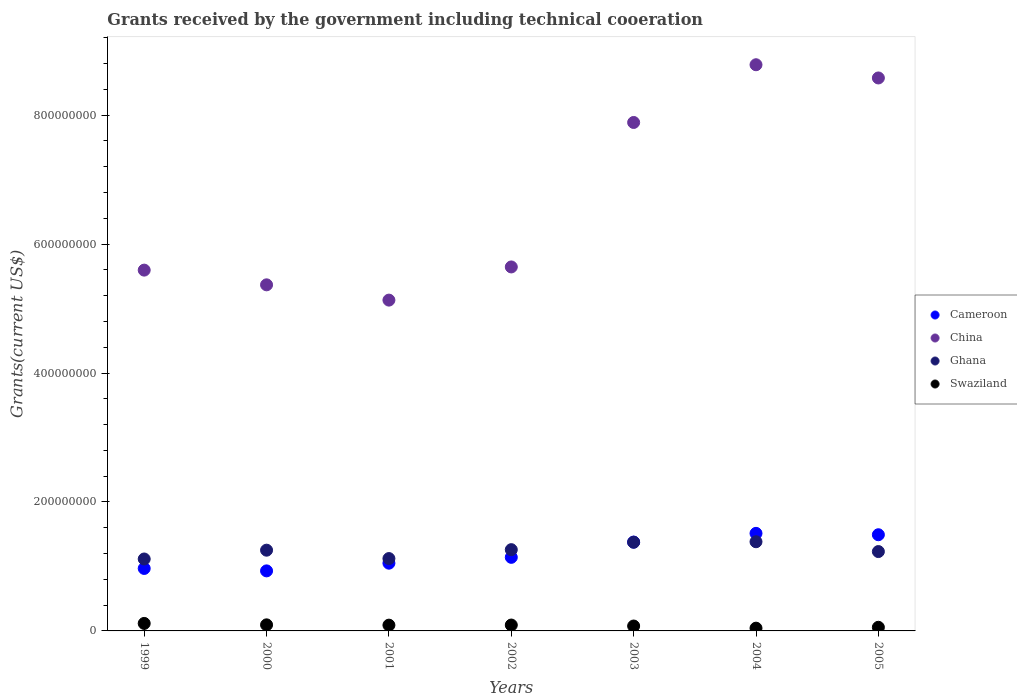How many different coloured dotlines are there?
Offer a very short reply. 4. Is the number of dotlines equal to the number of legend labels?
Provide a succinct answer. Yes. What is the total grants received by the government in Swaziland in 2000?
Offer a very short reply. 9.42e+06. Across all years, what is the maximum total grants received by the government in China?
Your answer should be compact. 8.78e+08. Across all years, what is the minimum total grants received by the government in Cameroon?
Your response must be concise. 9.31e+07. In which year was the total grants received by the government in China maximum?
Your answer should be compact. 2004. What is the total total grants received by the government in China in the graph?
Your answer should be very brief. 4.70e+09. What is the difference between the total grants received by the government in China in 1999 and that in 2003?
Provide a short and direct response. -2.29e+08. What is the difference between the total grants received by the government in Ghana in 1999 and the total grants received by the government in China in 2000?
Provide a succinct answer. -4.25e+08. What is the average total grants received by the government in Swaziland per year?
Give a very brief answer. 8.09e+06. In the year 2004, what is the difference between the total grants received by the government in China and total grants received by the government in Cameroon?
Keep it short and to the point. 7.27e+08. What is the ratio of the total grants received by the government in Swaziland in 2001 to that in 2003?
Offer a terse response. 1.18. Is the total grants received by the government in Ghana in 1999 less than that in 2002?
Your answer should be very brief. Yes. What is the difference between the highest and the second highest total grants received by the government in China?
Provide a short and direct response. 2.05e+07. What is the difference between the highest and the lowest total grants received by the government in Cameroon?
Your response must be concise. 5.82e+07. In how many years, is the total grants received by the government in China greater than the average total grants received by the government in China taken over all years?
Keep it short and to the point. 3. Does the total grants received by the government in Swaziland monotonically increase over the years?
Offer a very short reply. No. Is the total grants received by the government in Swaziland strictly greater than the total grants received by the government in Ghana over the years?
Offer a very short reply. No. How many dotlines are there?
Your answer should be very brief. 4. How many years are there in the graph?
Your answer should be compact. 7. What is the difference between two consecutive major ticks on the Y-axis?
Offer a terse response. 2.00e+08. Are the values on the major ticks of Y-axis written in scientific E-notation?
Offer a terse response. No. Where does the legend appear in the graph?
Your answer should be very brief. Center right. How are the legend labels stacked?
Make the answer very short. Vertical. What is the title of the graph?
Offer a very short reply. Grants received by the government including technical cooeration. Does "Macao" appear as one of the legend labels in the graph?
Provide a short and direct response. No. What is the label or title of the Y-axis?
Offer a terse response. Grants(current US$). What is the Grants(current US$) of Cameroon in 1999?
Give a very brief answer. 9.69e+07. What is the Grants(current US$) in China in 1999?
Give a very brief answer. 5.60e+08. What is the Grants(current US$) of Ghana in 1999?
Ensure brevity in your answer.  1.12e+08. What is the Grants(current US$) in Swaziland in 1999?
Your answer should be very brief. 1.16e+07. What is the Grants(current US$) in Cameroon in 2000?
Offer a very short reply. 9.31e+07. What is the Grants(current US$) in China in 2000?
Offer a terse response. 5.37e+08. What is the Grants(current US$) of Ghana in 2000?
Keep it short and to the point. 1.25e+08. What is the Grants(current US$) in Swaziland in 2000?
Make the answer very short. 9.42e+06. What is the Grants(current US$) of Cameroon in 2001?
Provide a short and direct response. 1.05e+08. What is the Grants(current US$) of China in 2001?
Offer a very short reply. 5.13e+08. What is the Grants(current US$) of Ghana in 2001?
Provide a short and direct response. 1.12e+08. What is the Grants(current US$) in Swaziland in 2001?
Give a very brief answer. 8.96e+06. What is the Grants(current US$) of Cameroon in 2002?
Keep it short and to the point. 1.14e+08. What is the Grants(current US$) of China in 2002?
Your response must be concise. 5.65e+08. What is the Grants(current US$) of Ghana in 2002?
Make the answer very short. 1.26e+08. What is the Grants(current US$) of Swaziland in 2002?
Provide a short and direct response. 9.12e+06. What is the Grants(current US$) in Cameroon in 2003?
Your response must be concise. 1.38e+08. What is the Grants(current US$) of China in 2003?
Offer a terse response. 7.89e+08. What is the Grants(current US$) of Ghana in 2003?
Ensure brevity in your answer.  1.38e+08. What is the Grants(current US$) in Swaziland in 2003?
Your answer should be very brief. 7.60e+06. What is the Grants(current US$) of Cameroon in 2004?
Ensure brevity in your answer.  1.51e+08. What is the Grants(current US$) in China in 2004?
Your answer should be very brief. 8.78e+08. What is the Grants(current US$) in Ghana in 2004?
Ensure brevity in your answer.  1.38e+08. What is the Grants(current US$) in Swaziland in 2004?
Offer a very short reply. 4.28e+06. What is the Grants(current US$) in Cameroon in 2005?
Make the answer very short. 1.49e+08. What is the Grants(current US$) in China in 2005?
Make the answer very short. 8.58e+08. What is the Grants(current US$) of Ghana in 2005?
Make the answer very short. 1.23e+08. What is the Grants(current US$) of Swaziland in 2005?
Offer a very short reply. 5.63e+06. Across all years, what is the maximum Grants(current US$) in Cameroon?
Make the answer very short. 1.51e+08. Across all years, what is the maximum Grants(current US$) in China?
Ensure brevity in your answer.  8.78e+08. Across all years, what is the maximum Grants(current US$) in Ghana?
Keep it short and to the point. 1.38e+08. Across all years, what is the maximum Grants(current US$) of Swaziland?
Your answer should be very brief. 1.16e+07. Across all years, what is the minimum Grants(current US$) in Cameroon?
Your answer should be compact. 9.31e+07. Across all years, what is the minimum Grants(current US$) in China?
Offer a terse response. 5.13e+08. Across all years, what is the minimum Grants(current US$) of Ghana?
Offer a very short reply. 1.12e+08. Across all years, what is the minimum Grants(current US$) of Swaziland?
Ensure brevity in your answer.  4.28e+06. What is the total Grants(current US$) in Cameroon in the graph?
Offer a terse response. 8.47e+08. What is the total Grants(current US$) of China in the graph?
Provide a short and direct response. 4.70e+09. What is the total Grants(current US$) of Ghana in the graph?
Your answer should be very brief. 8.74e+08. What is the total Grants(current US$) in Swaziland in the graph?
Your response must be concise. 5.66e+07. What is the difference between the Grants(current US$) of Cameroon in 1999 and that in 2000?
Offer a very short reply. 3.76e+06. What is the difference between the Grants(current US$) in China in 1999 and that in 2000?
Provide a short and direct response. 2.28e+07. What is the difference between the Grants(current US$) of Ghana in 1999 and that in 2000?
Offer a very short reply. -1.37e+07. What is the difference between the Grants(current US$) of Swaziland in 1999 and that in 2000?
Make the answer very short. 2.21e+06. What is the difference between the Grants(current US$) of Cameroon in 1999 and that in 2001?
Offer a terse response. -8.17e+06. What is the difference between the Grants(current US$) in China in 1999 and that in 2001?
Provide a succinct answer. 4.65e+07. What is the difference between the Grants(current US$) in Ghana in 1999 and that in 2001?
Your answer should be compact. -6.70e+05. What is the difference between the Grants(current US$) of Swaziland in 1999 and that in 2001?
Your response must be concise. 2.67e+06. What is the difference between the Grants(current US$) in Cameroon in 1999 and that in 2002?
Your response must be concise. -1.72e+07. What is the difference between the Grants(current US$) in China in 1999 and that in 2002?
Ensure brevity in your answer.  -4.94e+06. What is the difference between the Grants(current US$) of Ghana in 1999 and that in 2002?
Offer a terse response. -1.45e+07. What is the difference between the Grants(current US$) of Swaziland in 1999 and that in 2002?
Offer a terse response. 2.51e+06. What is the difference between the Grants(current US$) of Cameroon in 1999 and that in 2003?
Ensure brevity in your answer.  -4.09e+07. What is the difference between the Grants(current US$) in China in 1999 and that in 2003?
Offer a very short reply. -2.29e+08. What is the difference between the Grants(current US$) of Ghana in 1999 and that in 2003?
Offer a terse response. -2.60e+07. What is the difference between the Grants(current US$) of Swaziland in 1999 and that in 2003?
Keep it short and to the point. 4.03e+06. What is the difference between the Grants(current US$) in Cameroon in 1999 and that in 2004?
Your answer should be very brief. -5.44e+07. What is the difference between the Grants(current US$) in China in 1999 and that in 2004?
Keep it short and to the point. -3.19e+08. What is the difference between the Grants(current US$) in Ghana in 1999 and that in 2004?
Provide a succinct answer. -2.68e+07. What is the difference between the Grants(current US$) of Swaziland in 1999 and that in 2004?
Your answer should be compact. 7.35e+06. What is the difference between the Grants(current US$) in Cameroon in 1999 and that in 2005?
Offer a terse response. -5.23e+07. What is the difference between the Grants(current US$) in China in 1999 and that in 2005?
Provide a succinct answer. -2.98e+08. What is the difference between the Grants(current US$) of Ghana in 1999 and that in 2005?
Ensure brevity in your answer.  -1.15e+07. What is the difference between the Grants(current US$) in Cameroon in 2000 and that in 2001?
Your answer should be compact. -1.19e+07. What is the difference between the Grants(current US$) in China in 2000 and that in 2001?
Offer a very short reply. 2.37e+07. What is the difference between the Grants(current US$) of Ghana in 2000 and that in 2001?
Your response must be concise. 1.30e+07. What is the difference between the Grants(current US$) in Swaziland in 2000 and that in 2001?
Offer a terse response. 4.60e+05. What is the difference between the Grants(current US$) in Cameroon in 2000 and that in 2002?
Offer a very short reply. -2.10e+07. What is the difference between the Grants(current US$) in China in 2000 and that in 2002?
Offer a very short reply. -2.78e+07. What is the difference between the Grants(current US$) of Ghana in 2000 and that in 2002?
Ensure brevity in your answer.  -8.00e+05. What is the difference between the Grants(current US$) in Swaziland in 2000 and that in 2002?
Ensure brevity in your answer.  3.00e+05. What is the difference between the Grants(current US$) of Cameroon in 2000 and that in 2003?
Give a very brief answer. -4.46e+07. What is the difference between the Grants(current US$) of China in 2000 and that in 2003?
Offer a very short reply. -2.52e+08. What is the difference between the Grants(current US$) in Ghana in 2000 and that in 2003?
Your response must be concise. -1.23e+07. What is the difference between the Grants(current US$) in Swaziland in 2000 and that in 2003?
Make the answer very short. 1.82e+06. What is the difference between the Grants(current US$) of Cameroon in 2000 and that in 2004?
Keep it short and to the point. -5.82e+07. What is the difference between the Grants(current US$) of China in 2000 and that in 2004?
Provide a succinct answer. -3.41e+08. What is the difference between the Grants(current US$) in Ghana in 2000 and that in 2004?
Your response must be concise. -1.31e+07. What is the difference between the Grants(current US$) in Swaziland in 2000 and that in 2004?
Keep it short and to the point. 5.14e+06. What is the difference between the Grants(current US$) in Cameroon in 2000 and that in 2005?
Your response must be concise. -5.60e+07. What is the difference between the Grants(current US$) of China in 2000 and that in 2005?
Give a very brief answer. -3.21e+08. What is the difference between the Grants(current US$) of Ghana in 2000 and that in 2005?
Provide a short and direct response. 2.15e+06. What is the difference between the Grants(current US$) in Swaziland in 2000 and that in 2005?
Provide a succinct answer. 3.79e+06. What is the difference between the Grants(current US$) in Cameroon in 2001 and that in 2002?
Provide a short and direct response. -9.07e+06. What is the difference between the Grants(current US$) in China in 2001 and that in 2002?
Offer a terse response. -5.14e+07. What is the difference between the Grants(current US$) of Ghana in 2001 and that in 2002?
Make the answer very short. -1.38e+07. What is the difference between the Grants(current US$) in Cameroon in 2001 and that in 2003?
Your answer should be compact. -3.27e+07. What is the difference between the Grants(current US$) of China in 2001 and that in 2003?
Your answer should be compact. -2.76e+08. What is the difference between the Grants(current US$) in Ghana in 2001 and that in 2003?
Provide a short and direct response. -2.53e+07. What is the difference between the Grants(current US$) of Swaziland in 2001 and that in 2003?
Offer a terse response. 1.36e+06. What is the difference between the Grants(current US$) in Cameroon in 2001 and that in 2004?
Offer a terse response. -4.63e+07. What is the difference between the Grants(current US$) in China in 2001 and that in 2004?
Give a very brief answer. -3.65e+08. What is the difference between the Grants(current US$) in Ghana in 2001 and that in 2004?
Give a very brief answer. -2.61e+07. What is the difference between the Grants(current US$) in Swaziland in 2001 and that in 2004?
Make the answer very short. 4.68e+06. What is the difference between the Grants(current US$) in Cameroon in 2001 and that in 2005?
Make the answer very short. -4.41e+07. What is the difference between the Grants(current US$) of China in 2001 and that in 2005?
Offer a very short reply. -3.45e+08. What is the difference between the Grants(current US$) in Ghana in 2001 and that in 2005?
Give a very brief answer. -1.08e+07. What is the difference between the Grants(current US$) in Swaziland in 2001 and that in 2005?
Provide a short and direct response. 3.33e+06. What is the difference between the Grants(current US$) of Cameroon in 2002 and that in 2003?
Make the answer very short. -2.36e+07. What is the difference between the Grants(current US$) in China in 2002 and that in 2003?
Make the answer very short. -2.24e+08. What is the difference between the Grants(current US$) of Ghana in 2002 and that in 2003?
Provide a succinct answer. -1.15e+07. What is the difference between the Grants(current US$) in Swaziland in 2002 and that in 2003?
Give a very brief answer. 1.52e+06. What is the difference between the Grants(current US$) of Cameroon in 2002 and that in 2004?
Your answer should be compact. -3.72e+07. What is the difference between the Grants(current US$) of China in 2002 and that in 2004?
Offer a very short reply. -3.14e+08. What is the difference between the Grants(current US$) in Ghana in 2002 and that in 2004?
Offer a very short reply. -1.23e+07. What is the difference between the Grants(current US$) of Swaziland in 2002 and that in 2004?
Keep it short and to the point. 4.84e+06. What is the difference between the Grants(current US$) of Cameroon in 2002 and that in 2005?
Ensure brevity in your answer.  -3.50e+07. What is the difference between the Grants(current US$) of China in 2002 and that in 2005?
Provide a succinct answer. -2.93e+08. What is the difference between the Grants(current US$) in Ghana in 2002 and that in 2005?
Keep it short and to the point. 2.95e+06. What is the difference between the Grants(current US$) of Swaziland in 2002 and that in 2005?
Keep it short and to the point. 3.49e+06. What is the difference between the Grants(current US$) in Cameroon in 2003 and that in 2004?
Provide a short and direct response. -1.35e+07. What is the difference between the Grants(current US$) in China in 2003 and that in 2004?
Offer a terse response. -8.95e+07. What is the difference between the Grants(current US$) of Ghana in 2003 and that in 2004?
Ensure brevity in your answer.  -7.60e+05. What is the difference between the Grants(current US$) of Swaziland in 2003 and that in 2004?
Make the answer very short. 3.32e+06. What is the difference between the Grants(current US$) in Cameroon in 2003 and that in 2005?
Your answer should be compact. -1.14e+07. What is the difference between the Grants(current US$) of China in 2003 and that in 2005?
Make the answer very short. -6.90e+07. What is the difference between the Grants(current US$) in Ghana in 2003 and that in 2005?
Make the answer very short. 1.45e+07. What is the difference between the Grants(current US$) in Swaziland in 2003 and that in 2005?
Your answer should be very brief. 1.97e+06. What is the difference between the Grants(current US$) in Cameroon in 2004 and that in 2005?
Ensure brevity in your answer.  2.14e+06. What is the difference between the Grants(current US$) of China in 2004 and that in 2005?
Your response must be concise. 2.05e+07. What is the difference between the Grants(current US$) in Ghana in 2004 and that in 2005?
Ensure brevity in your answer.  1.52e+07. What is the difference between the Grants(current US$) of Swaziland in 2004 and that in 2005?
Your response must be concise. -1.35e+06. What is the difference between the Grants(current US$) in Cameroon in 1999 and the Grants(current US$) in China in 2000?
Ensure brevity in your answer.  -4.40e+08. What is the difference between the Grants(current US$) in Cameroon in 1999 and the Grants(current US$) in Ghana in 2000?
Make the answer very short. -2.83e+07. What is the difference between the Grants(current US$) of Cameroon in 1999 and the Grants(current US$) of Swaziland in 2000?
Your answer should be very brief. 8.75e+07. What is the difference between the Grants(current US$) of China in 1999 and the Grants(current US$) of Ghana in 2000?
Provide a short and direct response. 4.34e+08. What is the difference between the Grants(current US$) of China in 1999 and the Grants(current US$) of Swaziland in 2000?
Your answer should be compact. 5.50e+08. What is the difference between the Grants(current US$) of Ghana in 1999 and the Grants(current US$) of Swaziland in 2000?
Offer a terse response. 1.02e+08. What is the difference between the Grants(current US$) of Cameroon in 1999 and the Grants(current US$) of China in 2001?
Make the answer very short. -4.16e+08. What is the difference between the Grants(current US$) in Cameroon in 1999 and the Grants(current US$) in Ghana in 2001?
Your answer should be compact. -1.53e+07. What is the difference between the Grants(current US$) in Cameroon in 1999 and the Grants(current US$) in Swaziland in 2001?
Provide a short and direct response. 8.79e+07. What is the difference between the Grants(current US$) of China in 1999 and the Grants(current US$) of Ghana in 2001?
Offer a terse response. 4.47e+08. What is the difference between the Grants(current US$) in China in 1999 and the Grants(current US$) in Swaziland in 2001?
Provide a succinct answer. 5.51e+08. What is the difference between the Grants(current US$) in Ghana in 1999 and the Grants(current US$) in Swaziland in 2001?
Provide a short and direct response. 1.03e+08. What is the difference between the Grants(current US$) in Cameroon in 1999 and the Grants(current US$) in China in 2002?
Give a very brief answer. -4.68e+08. What is the difference between the Grants(current US$) of Cameroon in 1999 and the Grants(current US$) of Ghana in 2002?
Ensure brevity in your answer.  -2.91e+07. What is the difference between the Grants(current US$) in Cameroon in 1999 and the Grants(current US$) in Swaziland in 2002?
Your answer should be compact. 8.78e+07. What is the difference between the Grants(current US$) of China in 1999 and the Grants(current US$) of Ghana in 2002?
Your answer should be compact. 4.34e+08. What is the difference between the Grants(current US$) in China in 1999 and the Grants(current US$) in Swaziland in 2002?
Offer a terse response. 5.50e+08. What is the difference between the Grants(current US$) of Ghana in 1999 and the Grants(current US$) of Swaziland in 2002?
Offer a terse response. 1.02e+08. What is the difference between the Grants(current US$) of Cameroon in 1999 and the Grants(current US$) of China in 2003?
Your answer should be compact. -6.92e+08. What is the difference between the Grants(current US$) of Cameroon in 1999 and the Grants(current US$) of Ghana in 2003?
Offer a very short reply. -4.07e+07. What is the difference between the Grants(current US$) of Cameroon in 1999 and the Grants(current US$) of Swaziland in 2003?
Offer a terse response. 8.93e+07. What is the difference between the Grants(current US$) in China in 1999 and the Grants(current US$) in Ghana in 2003?
Offer a terse response. 4.22e+08. What is the difference between the Grants(current US$) of China in 1999 and the Grants(current US$) of Swaziland in 2003?
Provide a short and direct response. 5.52e+08. What is the difference between the Grants(current US$) in Ghana in 1999 and the Grants(current US$) in Swaziland in 2003?
Your response must be concise. 1.04e+08. What is the difference between the Grants(current US$) of Cameroon in 1999 and the Grants(current US$) of China in 2004?
Keep it short and to the point. -7.81e+08. What is the difference between the Grants(current US$) in Cameroon in 1999 and the Grants(current US$) in Ghana in 2004?
Keep it short and to the point. -4.14e+07. What is the difference between the Grants(current US$) in Cameroon in 1999 and the Grants(current US$) in Swaziland in 2004?
Offer a very short reply. 9.26e+07. What is the difference between the Grants(current US$) of China in 1999 and the Grants(current US$) of Ghana in 2004?
Provide a succinct answer. 4.21e+08. What is the difference between the Grants(current US$) in China in 1999 and the Grants(current US$) in Swaziland in 2004?
Your answer should be compact. 5.55e+08. What is the difference between the Grants(current US$) of Ghana in 1999 and the Grants(current US$) of Swaziland in 2004?
Give a very brief answer. 1.07e+08. What is the difference between the Grants(current US$) of Cameroon in 1999 and the Grants(current US$) of China in 2005?
Provide a succinct answer. -7.61e+08. What is the difference between the Grants(current US$) in Cameroon in 1999 and the Grants(current US$) in Ghana in 2005?
Make the answer very short. -2.62e+07. What is the difference between the Grants(current US$) in Cameroon in 1999 and the Grants(current US$) in Swaziland in 2005?
Provide a short and direct response. 9.13e+07. What is the difference between the Grants(current US$) of China in 1999 and the Grants(current US$) of Ghana in 2005?
Your answer should be compact. 4.37e+08. What is the difference between the Grants(current US$) in China in 1999 and the Grants(current US$) in Swaziland in 2005?
Your response must be concise. 5.54e+08. What is the difference between the Grants(current US$) in Ghana in 1999 and the Grants(current US$) in Swaziland in 2005?
Provide a succinct answer. 1.06e+08. What is the difference between the Grants(current US$) in Cameroon in 2000 and the Grants(current US$) in China in 2001?
Make the answer very short. -4.20e+08. What is the difference between the Grants(current US$) of Cameroon in 2000 and the Grants(current US$) of Ghana in 2001?
Your answer should be very brief. -1.91e+07. What is the difference between the Grants(current US$) of Cameroon in 2000 and the Grants(current US$) of Swaziland in 2001?
Your answer should be compact. 8.42e+07. What is the difference between the Grants(current US$) in China in 2000 and the Grants(current US$) in Ghana in 2001?
Your answer should be compact. 4.25e+08. What is the difference between the Grants(current US$) in China in 2000 and the Grants(current US$) in Swaziland in 2001?
Make the answer very short. 5.28e+08. What is the difference between the Grants(current US$) in Ghana in 2000 and the Grants(current US$) in Swaziland in 2001?
Ensure brevity in your answer.  1.16e+08. What is the difference between the Grants(current US$) of Cameroon in 2000 and the Grants(current US$) of China in 2002?
Keep it short and to the point. -4.71e+08. What is the difference between the Grants(current US$) of Cameroon in 2000 and the Grants(current US$) of Ghana in 2002?
Give a very brief answer. -3.29e+07. What is the difference between the Grants(current US$) in Cameroon in 2000 and the Grants(current US$) in Swaziland in 2002?
Give a very brief answer. 8.40e+07. What is the difference between the Grants(current US$) of China in 2000 and the Grants(current US$) of Ghana in 2002?
Your answer should be very brief. 4.11e+08. What is the difference between the Grants(current US$) in China in 2000 and the Grants(current US$) in Swaziland in 2002?
Offer a very short reply. 5.28e+08. What is the difference between the Grants(current US$) of Ghana in 2000 and the Grants(current US$) of Swaziland in 2002?
Provide a succinct answer. 1.16e+08. What is the difference between the Grants(current US$) in Cameroon in 2000 and the Grants(current US$) in China in 2003?
Your response must be concise. -6.95e+08. What is the difference between the Grants(current US$) in Cameroon in 2000 and the Grants(current US$) in Ghana in 2003?
Offer a very short reply. -4.44e+07. What is the difference between the Grants(current US$) of Cameroon in 2000 and the Grants(current US$) of Swaziland in 2003?
Your answer should be compact. 8.55e+07. What is the difference between the Grants(current US$) of China in 2000 and the Grants(current US$) of Ghana in 2003?
Your response must be concise. 3.99e+08. What is the difference between the Grants(current US$) in China in 2000 and the Grants(current US$) in Swaziland in 2003?
Make the answer very short. 5.29e+08. What is the difference between the Grants(current US$) of Ghana in 2000 and the Grants(current US$) of Swaziland in 2003?
Provide a short and direct response. 1.18e+08. What is the difference between the Grants(current US$) of Cameroon in 2000 and the Grants(current US$) of China in 2004?
Ensure brevity in your answer.  -7.85e+08. What is the difference between the Grants(current US$) in Cameroon in 2000 and the Grants(current US$) in Ghana in 2004?
Your answer should be compact. -4.52e+07. What is the difference between the Grants(current US$) of Cameroon in 2000 and the Grants(current US$) of Swaziland in 2004?
Your response must be concise. 8.88e+07. What is the difference between the Grants(current US$) of China in 2000 and the Grants(current US$) of Ghana in 2004?
Your answer should be compact. 3.98e+08. What is the difference between the Grants(current US$) in China in 2000 and the Grants(current US$) in Swaziland in 2004?
Your response must be concise. 5.33e+08. What is the difference between the Grants(current US$) of Ghana in 2000 and the Grants(current US$) of Swaziland in 2004?
Give a very brief answer. 1.21e+08. What is the difference between the Grants(current US$) of Cameroon in 2000 and the Grants(current US$) of China in 2005?
Provide a short and direct response. -7.65e+08. What is the difference between the Grants(current US$) in Cameroon in 2000 and the Grants(current US$) in Ghana in 2005?
Offer a very short reply. -3.00e+07. What is the difference between the Grants(current US$) in Cameroon in 2000 and the Grants(current US$) in Swaziland in 2005?
Offer a terse response. 8.75e+07. What is the difference between the Grants(current US$) of China in 2000 and the Grants(current US$) of Ghana in 2005?
Give a very brief answer. 4.14e+08. What is the difference between the Grants(current US$) in China in 2000 and the Grants(current US$) in Swaziland in 2005?
Make the answer very short. 5.31e+08. What is the difference between the Grants(current US$) in Ghana in 2000 and the Grants(current US$) in Swaziland in 2005?
Your answer should be compact. 1.20e+08. What is the difference between the Grants(current US$) of Cameroon in 2001 and the Grants(current US$) of China in 2002?
Offer a very short reply. -4.59e+08. What is the difference between the Grants(current US$) in Cameroon in 2001 and the Grants(current US$) in Ghana in 2002?
Ensure brevity in your answer.  -2.10e+07. What is the difference between the Grants(current US$) in Cameroon in 2001 and the Grants(current US$) in Swaziland in 2002?
Provide a succinct answer. 9.59e+07. What is the difference between the Grants(current US$) in China in 2001 and the Grants(current US$) in Ghana in 2002?
Provide a short and direct response. 3.87e+08. What is the difference between the Grants(current US$) in China in 2001 and the Grants(current US$) in Swaziland in 2002?
Provide a short and direct response. 5.04e+08. What is the difference between the Grants(current US$) in Ghana in 2001 and the Grants(current US$) in Swaziland in 2002?
Your response must be concise. 1.03e+08. What is the difference between the Grants(current US$) of Cameroon in 2001 and the Grants(current US$) of China in 2003?
Provide a succinct answer. -6.84e+08. What is the difference between the Grants(current US$) of Cameroon in 2001 and the Grants(current US$) of Ghana in 2003?
Make the answer very short. -3.25e+07. What is the difference between the Grants(current US$) in Cameroon in 2001 and the Grants(current US$) in Swaziland in 2003?
Provide a short and direct response. 9.75e+07. What is the difference between the Grants(current US$) in China in 2001 and the Grants(current US$) in Ghana in 2003?
Provide a succinct answer. 3.76e+08. What is the difference between the Grants(current US$) of China in 2001 and the Grants(current US$) of Swaziland in 2003?
Provide a short and direct response. 5.05e+08. What is the difference between the Grants(current US$) in Ghana in 2001 and the Grants(current US$) in Swaziland in 2003?
Offer a terse response. 1.05e+08. What is the difference between the Grants(current US$) in Cameroon in 2001 and the Grants(current US$) in China in 2004?
Your response must be concise. -7.73e+08. What is the difference between the Grants(current US$) in Cameroon in 2001 and the Grants(current US$) in Ghana in 2004?
Give a very brief answer. -3.32e+07. What is the difference between the Grants(current US$) of Cameroon in 2001 and the Grants(current US$) of Swaziland in 2004?
Provide a succinct answer. 1.01e+08. What is the difference between the Grants(current US$) in China in 2001 and the Grants(current US$) in Ghana in 2004?
Provide a short and direct response. 3.75e+08. What is the difference between the Grants(current US$) of China in 2001 and the Grants(current US$) of Swaziland in 2004?
Offer a very short reply. 5.09e+08. What is the difference between the Grants(current US$) in Ghana in 2001 and the Grants(current US$) in Swaziland in 2004?
Provide a succinct answer. 1.08e+08. What is the difference between the Grants(current US$) of Cameroon in 2001 and the Grants(current US$) of China in 2005?
Provide a succinct answer. -7.53e+08. What is the difference between the Grants(current US$) in Cameroon in 2001 and the Grants(current US$) in Ghana in 2005?
Your answer should be compact. -1.80e+07. What is the difference between the Grants(current US$) of Cameroon in 2001 and the Grants(current US$) of Swaziland in 2005?
Provide a short and direct response. 9.94e+07. What is the difference between the Grants(current US$) in China in 2001 and the Grants(current US$) in Ghana in 2005?
Your response must be concise. 3.90e+08. What is the difference between the Grants(current US$) of China in 2001 and the Grants(current US$) of Swaziland in 2005?
Your answer should be very brief. 5.07e+08. What is the difference between the Grants(current US$) of Ghana in 2001 and the Grants(current US$) of Swaziland in 2005?
Your answer should be compact. 1.07e+08. What is the difference between the Grants(current US$) in Cameroon in 2002 and the Grants(current US$) in China in 2003?
Offer a very short reply. -6.74e+08. What is the difference between the Grants(current US$) in Cameroon in 2002 and the Grants(current US$) in Ghana in 2003?
Give a very brief answer. -2.34e+07. What is the difference between the Grants(current US$) of Cameroon in 2002 and the Grants(current US$) of Swaziland in 2003?
Ensure brevity in your answer.  1.07e+08. What is the difference between the Grants(current US$) in China in 2002 and the Grants(current US$) in Ghana in 2003?
Your answer should be compact. 4.27e+08. What is the difference between the Grants(current US$) in China in 2002 and the Grants(current US$) in Swaziland in 2003?
Ensure brevity in your answer.  5.57e+08. What is the difference between the Grants(current US$) of Ghana in 2002 and the Grants(current US$) of Swaziland in 2003?
Make the answer very short. 1.18e+08. What is the difference between the Grants(current US$) of Cameroon in 2002 and the Grants(current US$) of China in 2004?
Provide a short and direct response. -7.64e+08. What is the difference between the Grants(current US$) in Cameroon in 2002 and the Grants(current US$) in Ghana in 2004?
Make the answer very short. -2.42e+07. What is the difference between the Grants(current US$) in Cameroon in 2002 and the Grants(current US$) in Swaziland in 2004?
Your answer should be compact. 1.10e+08. What is the difference between the Grants(current US$) in China in 2002 and the Grants(current US$) in Ghana in 2004?
Make the answer very short. 4.26e+08. What is the difference between the Grants(current US$) of China in 2002 and the Grants(current US$) of Swaziland in 2004?
Provide a succinct answer. 5.60e+08. What is the difference between the Grants(current US$) of Ghana in 2002 and the Grants(current US$) of Swaziland in 2004?
Provide a short and direct response. 1.22e+08. What is the difference between the Grants(current US$) of Cameroon in 2002 and the Grants(current US$) of China in 2005?
Your response must be concise. -7.44e+08. What is the difference between the Grants(current US$) in Cameroon in 2002 and the Grants(current US$) in Ghana in 2005?
Give a very brief answer. -8.95e+06. What is the difference between the Grants(current US$) in Cameroon in 2002 and the Grants(current US$) in Swaziland in 2005?
Offer a very short reply. 1.08e+08. What is the difference between the Grants(current US$) of China in 2002 and the Grants(current US$) of Ghana in 2005?
Your answer should be very brief. 4.41e+08. What is the difference between the Grants(current US$) of China in 2002 and the Grants(current US$) of Swaziland in 2005?
Offer a terse response. 5.59e+08. What is the difference between the Grants(current US$) of Ghana in 2002 and the Grants(current US$) of Swaziland in 2005?
Keep it short and to the point. 1.20e+08. What is the difference between the Grants(current US$) of Cameroon in 2003 and the Grants(current US$) of China in 2004?
Offer a terse response. -7.40e+08. What is the difference between the Grants(current US$) in Cameroon in 2003 and the Grants(current US$) in Ghana in 2004?
Your answer should be very brief. -5.30e+05. What is the difference between the Grants(current US$) in Cameroon in 2003 and the Grants(current US$) in Swaziland in 2004?
Offer a very short reply. 1.34e+08. What is the difference between the Grants(current US$) of China in 2003 and the Grants(current US$) of Ghana in 2004?
Your response must be concise. 6.50e+08. What is the difference between the Grants(current US$) of China in 2003 and the Grants(current US$) of Swaziland in 2004?
Keep it short and to the point. 7.84e+08. What is the difference between the Grants(current US$) of Ghana in 2003 and the Grants(current US$) of Swaziland in 2004?
Your response must be concise. 1.33e+08. What is the difference between the Grants(current US$) in Cameroon in 2003 and the Grants(current US$) in China in 2005?
Offer a terse response. -7.20e+08. What is the difference between the Grants(current US$) of Cameroon in 2003 and the Grants(current US$) of Ghana in 2005?
Make the answer very short. 1.47e+07. What is the difference between the Grants(current US$) in Cameroon in 2003 and the Grants(current US$) in Swaziland in 2005?
Provide a succinct answer. 1.32e+08. What is the difference between the Grants(current US$) in China in 2003 and the Grants(current US$) in Ghana in 2005?
Provide a short and direct response. 6.66e+08. What is the difference between the Grants(current US$) in China in 2003 and the Grants(current US$) in Swaziland in 2005?
Ensure brevity in your answer.  7.83e+08. What is the difference between the Grants(current US$) in Ghana in 2003 and the Grants(current US$) in Swaziland in 2005?
Your answer should be very brief. 1.32e+08. What is the difference between the Grants(current US$) of Cameroon in 2004 and the Grants(current US$) of China in 2005?
Your answer should be compact. -7.06e+08. What is the difference between the Grants(current US$) in Cameroon in 2004 and the Grants(current US$) in Ghana in 2005?
Ensure brevity in your answer.  2.82e+07. What is the difference between the Grants(current US$) of Cameroon in 2004 and the Grants(current US$) of Swaziland in 2005?
Offer a very short reply. 1.46e+08. What is the difference between the Grants(current US$) in China in 2004 and the Grants(current US$) in Ghana in 2005?
Keep it short and to the point. 7.55e+08. What is the difference between the Grants(current US$) in China in 2004 and the Grants(current US$) in Swaziland in 2005?
Provide a short and direct response. 8.73e+08. What is the difference between the Grants(current US$) in Ghana in 2004 and the Grants(current US$) in Swaziland in 2005?
Give a very brief answer. 1.33e+08. What is the average Grants(current US$) of Cameroon per year?
Keep it short and to the point. 1.21e+08. What is the average Grants(current US$) of China per year?
Keep it short and to the point. 6.71e+08. What is the average Grants(current US$) in Ghana per year?
Ensure brevity in your answer.  1.25e+08. What is the average Grants(current US$) of Swaziland per year?
Provide a succinct answer. 8.09e+06. In the year 1999, what is the difference between the Grants(current US$) in Cameroon and Grants(current US$) in China?
Give a very brief answer. -4.63e+08. In the year 1999, what is the difference between the Grants(current US$) in Cameroon and Grants(current US$) in Ghana?
Offer a very short reply. -1.47e+07. In the year 1999, what is the difference between the Grants(current US$) of Cameroon and Grants(current US$) of Swaziland?
Keep it short and to the point. 8.53e+07. In the year 1999, what is the difference between the Grants(current US$) in China and Grants(current US$) in Ghana?
Offer a very short reply. 4.48e+08. In the year 1999, what is the difference between the Grants(current US$) of China and Grants(current US$) of Swaziland?
Your answer should be compact. 5.48e+08. In the year 1999, what is the difference between the Grants(current US$) in Ghana and Grants(current US$) in Swaziland?
Offer a terse response. 9.99e+07. In the year 2000, what is the difference between the Grants(current US$) in Cameroon and Grants(current US$) in China?
Offer a very short reply. -4.44e+08. In the year 2000, what is the difference between the Grants(current US$) in Cameroon and Grants(current US$) in Ghana?
Ensure brevity in your answer.  -3.21e+07. In the year 2000, what is the difference between the Grants(current US$) in Cameroon and Grants(current US$) in Swaziland?
Your answer should be very brief. 8.37e+07. In the year 2000, what is the difference between the Grants(current US$) of China and Grants(current US$) of Ghana?
Provide a succinct answer. 4.12e+08. In the year 2000, what is the difference between the Grants(current US$) of China and Grants(current US$) of Swaziland?
Offer a very short reply. 5.27e+08. In the year 2000, what is the difference between the Grants(current US$) in Ghana and Grants(current US$) in Swaziland?
Offer a terse response. 1.16e+08. In the year 2001, what is the difference between the Grants(current US$) in Cameroon and Grants(current US$) in China?
Offer a terse response. -4.08e+08. In the year 2001, what is the difference between the Grants(current US$) in Cameroon and Grants(current US$) in Ghana?
Your answer should be compact. -7.17e+06. In the year 2001, what is the difference between the Grants(current US$) in Cameroon and Grants(current US$) in Swaziland?
Provide a succinct answer. 9.61e+07. In the year 2001, what is the difference between the Grants(current US$) in China and Grants(current US$) in Ghana?
Your response must be concise. 4.01e+08. In the year 2001, what is the difference between the Grants(current US$) of China and Grants(current US$) of Swaziland?
Your response must be concise. 5.04e+08. In the year 2001, what is the difference between the Grants(current US$) of Ghana and Grants(current US$) of Swaziland?
Keep it short and to the point. 1.03e+08. In the year 2002, what is the difference between the Grants(current US$) of Cameroon and Grants(current US$) of China?
Your answer should be very brief. -4.50e+08. In the year 2002, what is the difference between the Grants(current US$) in Cameroon and Grants(current US$) in Ghana?
Ensure brevity in your answer.  -1.19e+07. In the year 2002, what is the difference between the Grants(current US$) of Cameroon and Grants(current US$) of Swaziland?
Offer a very short reply. 1.05e+08. In the year 2002, what is the difference between the Grants(current US$) of China and Grants(current US$) of Ghana?
Your answer should be very brief. 4.39e+08. In the year 2002, what is the difference between the Grants(current US$) of China and Grants(current US$) of Swaziland?
Make the answer very short. 5.55e+08. In the year 2002, what is the difference between the Grants(current US$) of Ghana and Grants(current US$) of Swaziland?
Your answer should be compact. 1.17e+08. In the year 2003, what is the difference between the Grants(current US$) of Cameroon and Grants(current US$) of China?
Offer a terse response. -6.51e+08. In the year 2003, what is the difference between the Grants(current US$) of Cameroon and Grants(current US$) of Swaziland?
Give a very brief answer. 1.30e+08. In the year 2003, what is the difference between the Grants(current US$) in China and Grants(current US$) in Ghana?
Your response must be concise. 6.51e+08. In the year 2003, what is the difference between the Grants(current US$) of China and Grants(current US$) of Swaziland?
Provide a succinct answer. 7.81e+08. In the year 2003, what is the difference between the Grants(current US$) of Ghana and Grants(current US$) of Swaziland?
Provide a short and direct response. 1.30e+08. In the year 2004, what is the difference between the Grants(current US$) of Cameroon and Grants(current US$) of China?
Offer a very short reply. -7.27e+08. In the year 2004, what is the difference between the Grants(current US$) of Cameroon and Grants(current US$) of Ghana?
Provide a short and direct response. 1.30e+07. In the year 2004, what is the difference between the Grants(current US$) in Cameroon and Grants(current US$) in Swaziland?
Provide a short and direct response. 1.47e+08. In the year 2004, what is the difference between the Grants(current US$) in China and Grants(current US$) in Ghana?
Make the answer very short. 7.40e+08. In the year 2004, what is the difference between the Grants(current US$) of China and Grants(current US$) of Swaziland?
Provide a succinct answer. 8.74e+08. In the year 2004, what is the difference between the Grants(current US$) of Ghana and Grants(current US$) of Swaziland?
Make the answer very short. 1.34e+08. In the year 2005, what is the difference between the Grants(current US$) in Cameroon and Grants(current US$) in China?
Give a very brief answer. -7.08e+08. In the year 2005, what is the difference between the Grants(current US$) of Cameroon and Grants(current US$) of Ghana?
Your answer should be compact. 2.61e+07. In the year 2005, what is the difference between the Grants(current US$) in Cameroon and Grants(current US$) in Swaziland?
Make the answer very short. 1.44e+08. In the year 2005, what is the difference between the Grants(current US$) in China and Grants(current US$) in Ghana?
Provide a short and direct response. 7.35e+08. In the year 2005, what is the difference between the Grants(current US$) in China and Grants(current US$) in Swaziland?
Make the answer very short. 8.52e+08. In the year 2005, what is the difference between the Grants(current US$) of Ghana and Grants(current US$) of Swaziland?
Provide a succinct answer. 1.17e+08. What is the ratio of the Grants(current US$) in Cameroon in 1999 to that in 2000?
Offer a very short reply. 1.04. What is the ratio of the Grants(current US$) of China in 1999 to that in 2000?
Offer a very short reply. 1.04. What is the ratio of the Grants(current US$) in Ghana in 1999 to that in 2000?
Ensure brevity in your answer.  0.89. What is the ratio of the Grants(current US$) in Swaziland in 1999 to that in 2000?
Your response must be concise. 1.23. What is the ratio of the Grants(current US$) of Cameroon in 1999 to that in 2001?
Provide a succinct answer. 0.92. What is the ratio of the Grants(current US$) in China in 1999 to that in 2001?
Make the answer very short. 1.09. What is the ratio of the Grants(current US$) in Ghana in 1999 to that in 2001?
Provide a succinct answer. 0.99. What is the ratio of the Grants(current US$) in Swaziland in 1999 to that in 2001?
Make the answer very short. 1.3. What is the ratio of the Grants(current US$) of Cameroon in 1999 to that in 2002?
Provide a short and direct response. 0.85. What is the ratio of the Grants(current US$) of China in 1999 to that in 2002?
Your answer should be very brief. 0.99. What is the ratio of the Grants(current US$) of Ghana in 1999 to that in 2002?
Your response must be concise. 0.89. What is the ratio of the Grants(current US$) in Swaziland in 1999 to that in 2002?
Offer a terse response. 1.28. What is the ratio of the Grants(current US$) in Cameroon in 1999 to that in 2003?
Give a very brief answer. 0.7. What is the ratio of the Grants(current US$) of China in 1999 to that in 2003?
Your answer should be compact. 0.71. What is the ratio of the Grants(current US$) in Ghana in 1999 to that in 2003?
Offer a very short reply. 0.81. What is the ratio of the Grants(current US$) in Swaziland in 1999 to that in 2003?
Your answer should be very brief. 1.53. What is the ratio of the Grants(current US$) in Cameroon in 1999 to that in 2004?
Ensure brevity in your answer.  0.64. What is the ratio of the Grants(current US$) in China in 1999 to that in 2004?
Make the answer very short. 0.64. What is the ratio of the Grants(current US$) in Ghana in 1999 to that in 2004?
Offer a very short reply. 0.81. What is the ratio of the Grants(current US$) in Swaziland in 1999 to that in 2004?
Ensure brevity in your answer.  2.72. What is the ratio of the Grants(current US$) in Cameroon in 1999 to that in 2005?
Offer a terse response. 0.65. What is the ratio of the Grants(current US$) in China in 1999 to that in 2005?
Ensure brevity in your answer.  0.65. What is the ratio of the Grants(current US$) in Ghana in 1999 to that in 2005?
Make the answer very short. 0.91. What is the ratio of the Grants(current US$) in Swaziland in 1999 to that in 2005?
Give a very brief answer. 2.07. What is the ratio of the Grants(current US$) of Cameroon in 2000 to that in 2001?
Keep it short and to the point. 0.89. What is the ratio of the Grants(current US$) in China in 2000 to that in 2001?
Keep it short and to the point. 1.05. What is the ratio of the Grants(current US$) of Ghana in 2000 to that in 2001?
Keep it short and to the point. 1.12. What is the ratio of the Grants(current US$) of Swaziland in 2000 to that in 2001?
Provide a short and direct response. 1.05. What is the ratio of the Grants(current US$) in Cameroon in 2000 to that in 2002?
Offer a terse response. 0.82. What is the ratio of the Grants(current US$) of China in 2000 to that in 2002?
Your response must be concise. 0.95. What is the ratio of the Grants(current US$) of Ghana in 2000 to that in 2002?
Give a very brief answer. 0.99. What is the ratio of the Grants(current US$) in Swaziland in 2000 to that in 2002?
Give a very brief answer. 1.03. What is the ratio of the Grants(current US$) of Cameroon in 2000 to that in 2003?
Make the answer very short. 0.68. What is the ratio of the Grants(current US$) in China in 2000 to that in 2003?
Offer a terse response. 0.68. What is the ratio of the Grants(current US$) of Ghana in 2000 to that in 2003?
Keep it short and to the point. 0.91. What is the ratio of the Grants(current US$) of Swaziland in 2000 to that in 2003?
Your answer should be very brief. 1.24. What is the ratio of the Grants(current US$) of Cameroon in 2000 to that in 2004?
Ensure brevity in your answer.  0.62. What is the ratio of the Grants(current US$) of China in 2000 to that in 2004?
Keep it short and to the point. 0.61. What is the ratio of the Grants(current US$) of Ghana in 2000 to that in 2004?
Offer a very short reply. 0.91. What is the ratio of the Grants(current US$) of Swaziland in 2000 to that in 2004?
Offer a terse response. 2.2. What is the ratio of the Grants(current US$) in Cameroon in 2000 to that in 2005?
Provide a short and direct response. 0.62. What is the ratio of the Grants(current US$) of China in 2000 to that in 2005?
Offer a very short reply. 0.63. What is the ratio of the Grants(current US$) in Ghana in 2000 to that in 2005?
Offer a very short reply. 1.02. What is the ratio of the Grants(current US$) in Swaziland in 2000 to that in 2005?
Give a very brief answer. 1.67. What is the ratio of the Grants(current US$) of Cameroon in 2001 to that in 2002?
Your answer should be compact. 0.92. What is the ratio of the Grants(current US$) of China in 2001 to that in 2002?
Provide a succinct answer. 0.91. What is the ratio of the Grants(current US$) of Ghana in 2001 to that in 2002?
Give a very brief answer. 0.89. What is the ratio of the Grants(current US$) of Swaziland in 2001 to that in 2002?
Offer a terse response. 0.98. What is the ratio of the Grants(current US$) of Cameroon in 2001 to that in 2003?
Provide a short and direct response. 0.76. What is the ratio of the Grants(current US$) in China in 2001 to that in 2003?
Offer a very short reply. 0.65. What is the ratio of the Grants(current US$) in Ghana in 2001 to that in 2003?
Provide a short and direct response. 0.82. What is the ratio of the Grants(current US$) of Swaziland in 2001 to that in 2003?
Provide a short and direct response. 1.18. What is the ratio of the Grants(current US$) of Cameroon in 2001 to that in 2004?
Ensure brevity in your answer.  0.69. What is the ratio of the Grants(current US$) in China in 2001 to that in 2004?
Provide a short and direct response. 0.58. What is the ratio of the Grants(current US$) of Ghana in 2001 to that in 2004?
Offer a terse response. 0.81. What is the ratio of the Grants(current US$) in Swaziland in 2001 to that in 2004?
Offer a terse response. 2.09. What is the ratio of the Grants(current US$) of Cameroon in 2001 to that in 2005?
Keep it short and to the point. 0.7. What is the ratio of the Grants(current US$) of China in 2001 to that in 2005?
Offer a terse response. 0.6. What is the ratio of the Grants(current US$) in Ghana in 2001 to that in 2005?
Provide a short and direct response. 0.91. What is the ratio of the Grants(current US$) of Swaziland in 2001 to that in 2005?
Your answer should be very brief. 1.59. What is the ratio of the Grants(current US$) in Cameroon in 2002 to that in 2003?
Your response must be concise. 0.83. What is the ratio of the Grants(current US$) in China in 2002 to that in 2003?
Your answer should be very brief. 0.72. What is the ratio of the Grants(current US$) in Ghana in 2002 to that in 2003?
Offer a very short reply. 0.92. What is the ratio of the Grants(current US$) of Cameroon in 2002 to that in 2004?
Your answer should be compact. 0.75. What is the ratio of the Grants(current US$) in China in 2002 to that in 2004?
Give a very brief answer. 0.64. What is the ratio of the Grants(current US$) in Ghana in 2002 to that in 2004?
Ensure brevity in your answer.  0.91. What is the ratio of the Grants(current US$) of Swaziland in 2002 to that in 2004?
Provide a short and direct response. 2.13. What is the ratio of the Grants(current US$) of Cameroon in 2002 to that in 2005?
Your answer should be very brief. 0.77. What is the ratio of the Grants(current US$) of China in 2002 to that in 2005?
Ensure brevity in your answer.  0.66. What is the ratio of the Grants(current US$) in Swaziland in 2002 to that in 2005?
Offer a terse response. 1.62. What is the ratio of the Grants(current US$) in Cameroon in 2003 to that in 2004?
Make the answer very short. 0.91. What is the ratio of the Grants(current US$) of China in 2003 to that in 2004?
Provide a succinct answer. 0.9. What is the ratio of the Grants(current US$) in Swaziland in 2003 to that in 2004?
Give a very brief answer. 1.78. What is the ratio of the Grants(current US$) in Cameroon in 2003 to that in 2005?
Give a very brief answer. 0.92. What is the ratio of the Grants(current US$) of China in 2003 to that in 2005?
Give a very brief answer. 0.92. What is the ratio of the Grants(current US$) of Ghana in 2003 to that in 2005?
Offer a very short reply. 1.12. What is the ratio of the Grants(current US$) of Swaziland in 2003 to that in 2005?
Offer a terse response. 1.35. What is the ratio of the Grants(current US$) of Cameroon in 2004 to that in 2005?
Make the answer very short. 1.01. What is the ratio of the Grants(current US$) in China in 2004 to that in 2005?
Your response must be concise. 1.02. What is the ratio of the Grants(current US$) in Ghana in 2004 to that in 2005?
Keep it short and to the point. 1.12. What is the ratio of the Grants(current US$) in Swaziland in 2004 to that in 2005?
Your answer should be very brief. 0.76. What is the difference between the highest and the second highest Grants(current US$) of Cameroon?
Offer a very short reply. 2.14e+06. What is the difference between the highest and the second highest Grants(current US$) in China?
Your response must be concise. 2.05e+07. What is the difference between the highest and the second highest Grants(current US$) of Ghana?
Your answer should be compact. 7.60e+05. What is the difference between the highest and the second highest Grants(current US$) in Swaziland?
Offer a terse response. 2.21e+06. What is the difference between the highest and the lowest Grants(current US$) of Cameroon?
Keep it short and to the point. 5.82e+07. What is the difference between the highest and the lowest Grants(current US$) in China?
Make the answer very short. 3.65e+08. What is the difference between the highest and the lowest Grants(current US$) in Ghana?
Your answer should be very brief. 2.68e+07. What is the difference between the highest and the lowest Grants(current US$) in Swaziland?
Provide a short and direct response. 7.35e+06. 